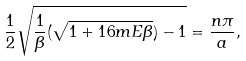Convert formula to latex. <formula><loc_0><loc_0><loc_500><loc_500>\frac { 1 } { 2 } \sqrt { \frac { 1 } { \beta } ( \sqrt { 1 + 1 6 m E \beta } ) - 1 } = \frac { n \pi } { a } ,</formula> 